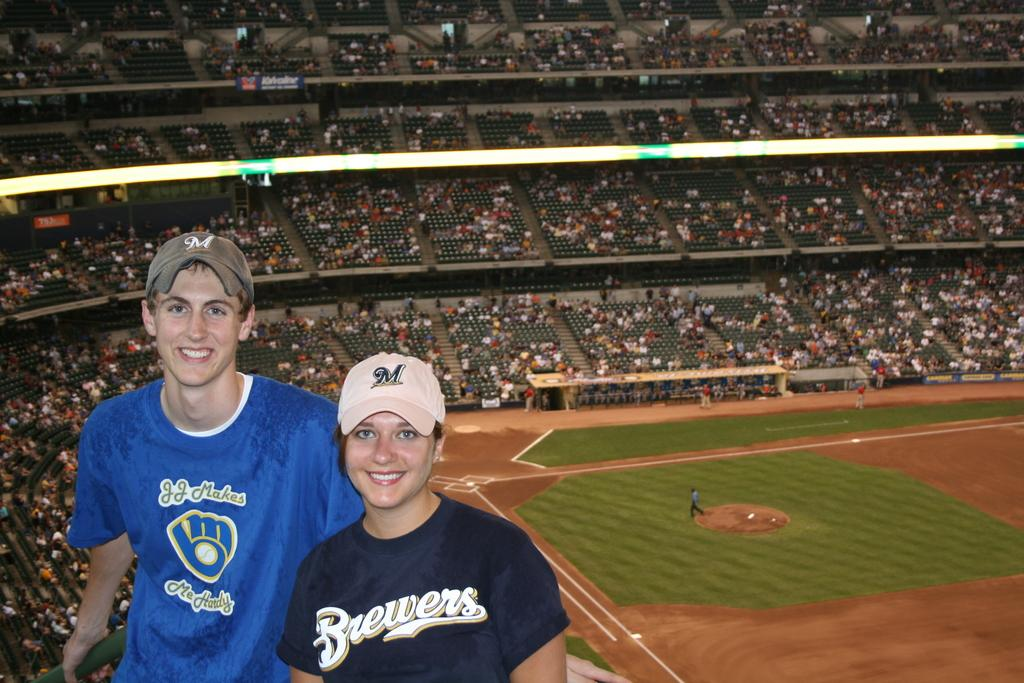<image>
Create a compact narrative representing the image presented. JJ Makes Me Hardy and Brewers are shown on these two fan's jerseys. 